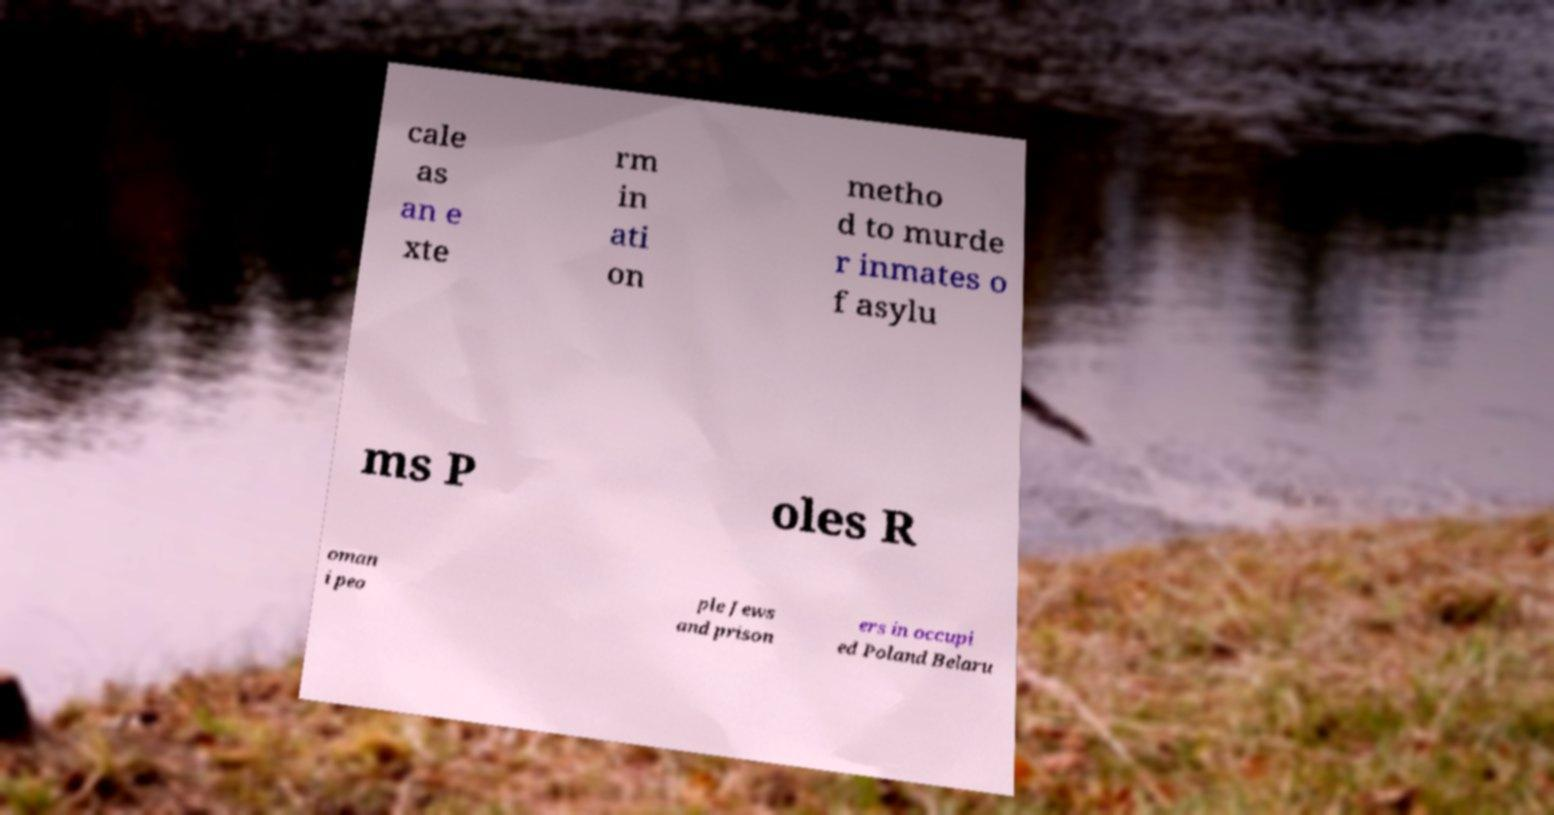Please read and relay the text visible in this image. What does it say? cale as an e xte rm in ati on metho d to murde r inmates o f asylu ms P oles R oman i peo ple Jews and prison ers in occupi ed Poland Belaru 